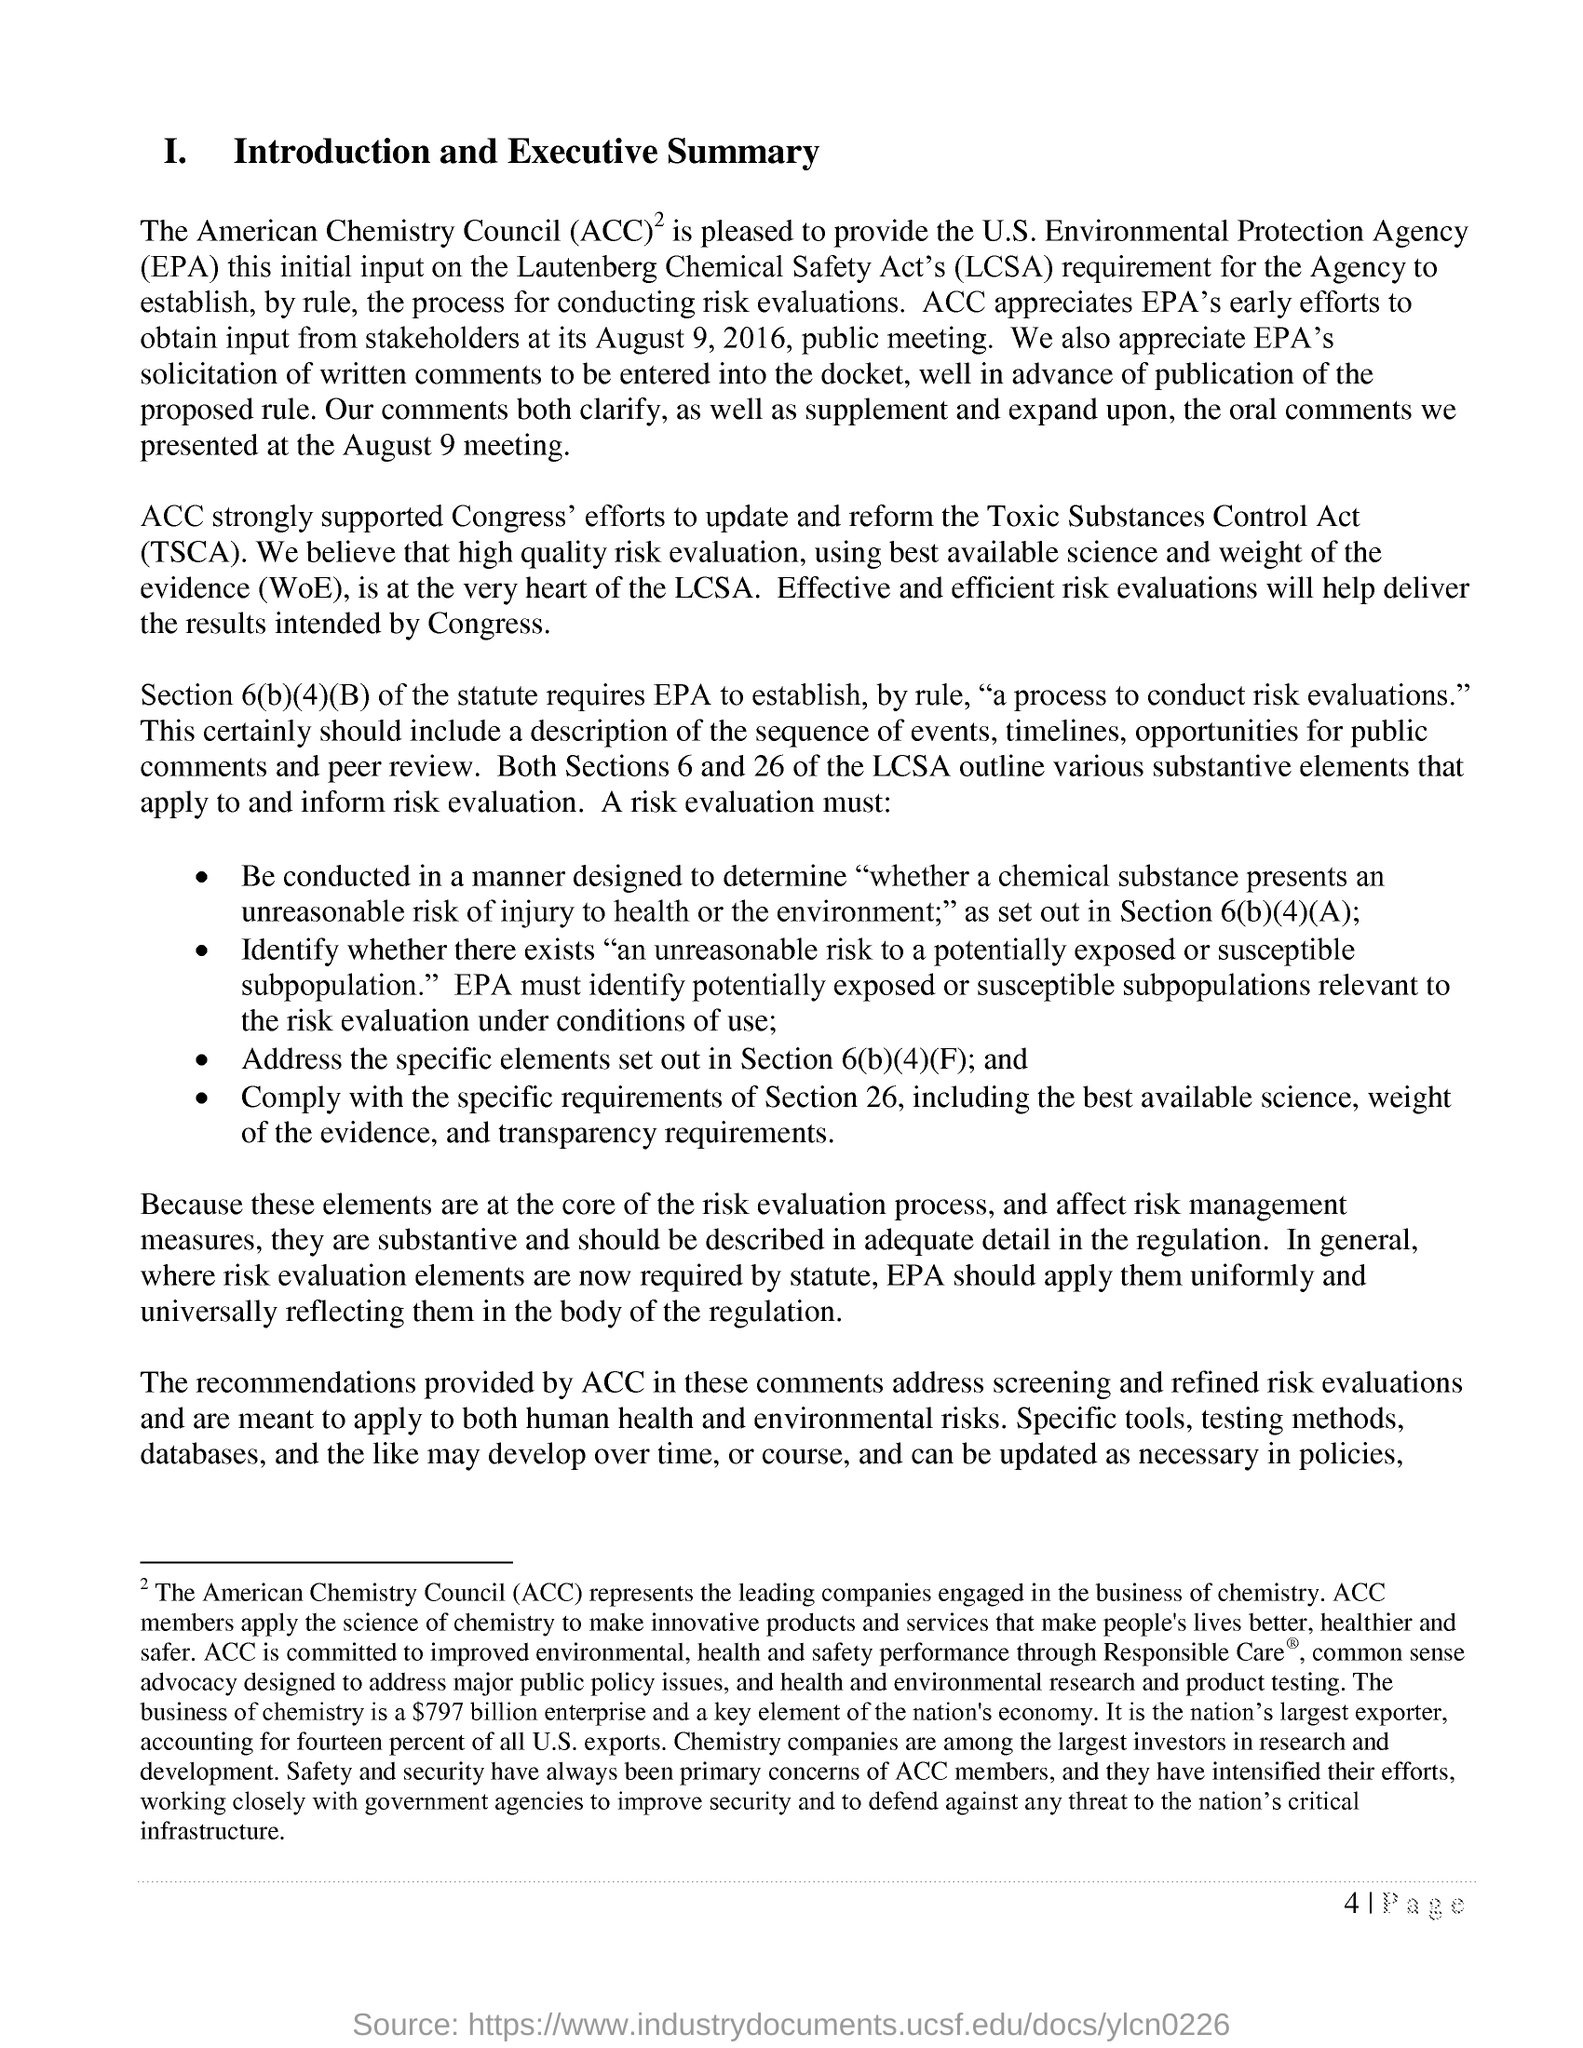What does TSCA stands for?
Offer a terse response. Toxic Substances Control Act. What will help deliver the results intended by congress?
Your answer should be compact. Effective and efficient risk evaluations. What is the abbreviation of The American Chemistry Council?
Provide a succinct answer. ACC. ACC strongly supported Congress' effort for which act?
Give a very brief answer. Toxic Substances Control Act. 